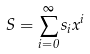<formula> <loc_0><loc_0><loc_500><loc_500>S = \sum _ { i = 0 } ^ { \infty } s _ { i } x ^ { i }</formula> 